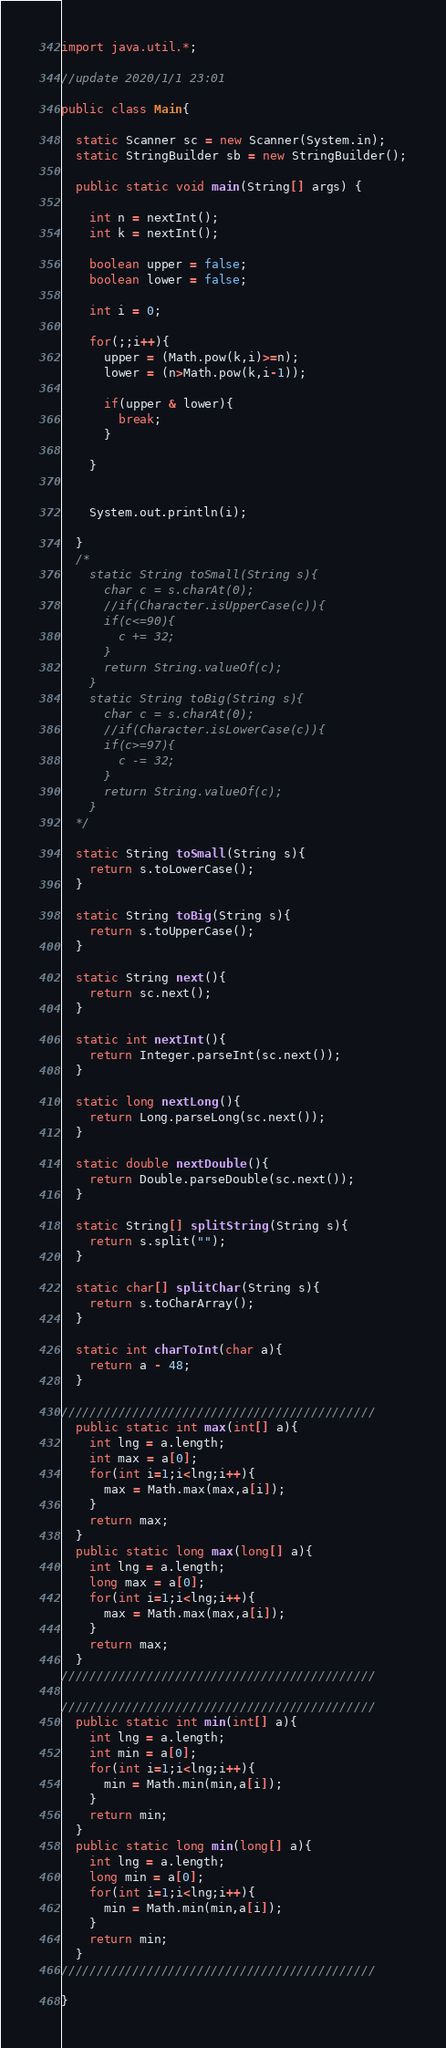<code> <loc_0><loc_0><loc_500><loc_500><_Java_>import java.util.*;

//update 2020/1/1 23:01

public class Main{

  static Scanner sc = new Scanner(System.in);
  static StringBuilder sb = new StringBuilder();

  public static void main(String[] args) {

    int n = nextInt();
    int k = nextInt();

    boolean upper = false;
    boolean lower = false;

    int i = 0;

    for(;;i++){
      upper = (Math.pow(k,i)>=n);
      lower = (n>Math.pow(k,i-1));

      if(upper & lower){
        break;
      }

    }


    System.out.println(i);

  }
  /*
    static String toSmall(String s){
      char c = s.charAt(0);
      //if(Character.isUpperCase(c)){
      if(c<=90){
        c += 32;
      }
      return String.valueOf(c);
    }
    static String toBig(String s){
      char c = s.charAt(0);
      //if(Character.isLowerCase(c)){
      if(c>=97){
        c -= 32;
      }
      return String.valueOf(c);
    }
  */

  static String toSmall(String s){
    return s.toLowerCase();
  }

  static String toBig(String s){
    return s.toUpperCase();
  }

  static String next(){
    return sc.next();
  }

  static int nextInt(){
    return Integer.parseInt(sc.next());
  }

  static long nextLong(){
    return Long.parseLong(sc.next());
  }

  static double nextDouble(){
    return Double.parseDouble(sc.next());
  }

  static String[] splitString(String s){
    return s.split("");
  }

  static char[] splitChar(String s){
    return s.toCharArray();
  }

  static int charToInt(char a){
    return a - 48;
  }

////////////////////////////////////////////
  public static int max(int[] a){
    int lng = a.length;
    int max = a[0];
    for(int i=1;i<lng;i++){
      max = Math.max(max,a[i]);
    }
    return max;
  }
  public static long max(long[] a){
    int lng = a.length;
    long max = a[0];
    for(int i=1;i<lng;i++){
      max = Math.max(max,a[i]);
    }
    return max;
  }
////////////////////////////////////////////

////////////////////////////////////////////
  public static int min(int[] a){
    int lng = a.length;
    int min = a[0];
    for(int i=1;i<lng;i++){
      min = Math.min(min,a[i]);
    }
    return min;
  }
  public static long min(long[] a){
    int lng = a.length;
    long min = a[0];
    for(int i=1;i<lng;i++){
      min = Math.min(min,a[i]);
    }
    return min;
  }
////////////////////////////////////////////

}
</code> 